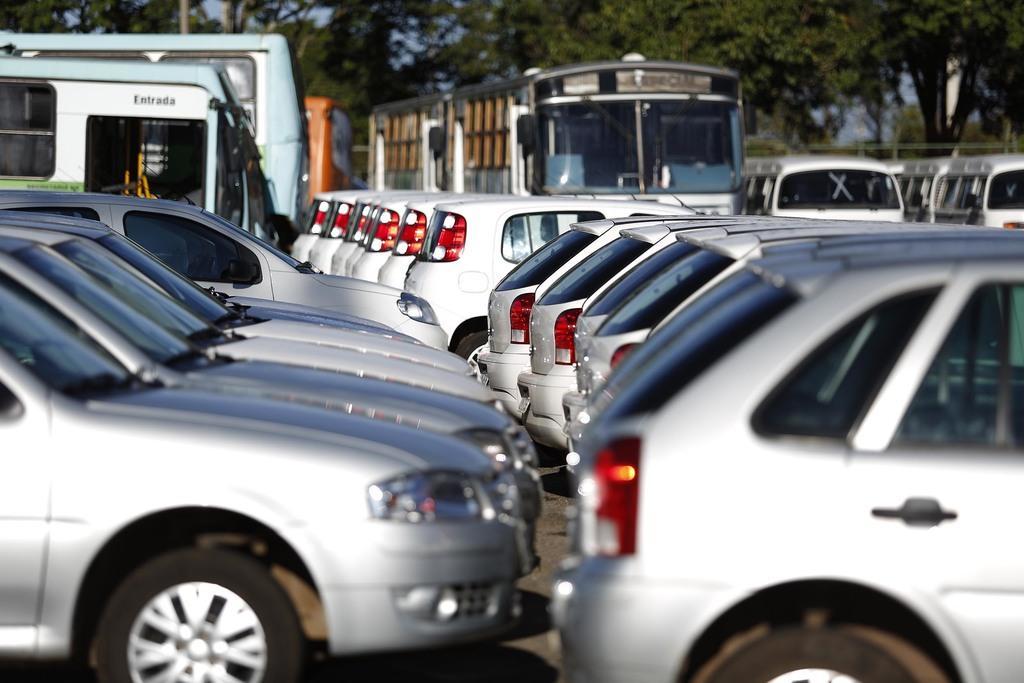Describe this image in one or two sentences. In this picture we can see vehicles on the road and in the background we can see trees. 